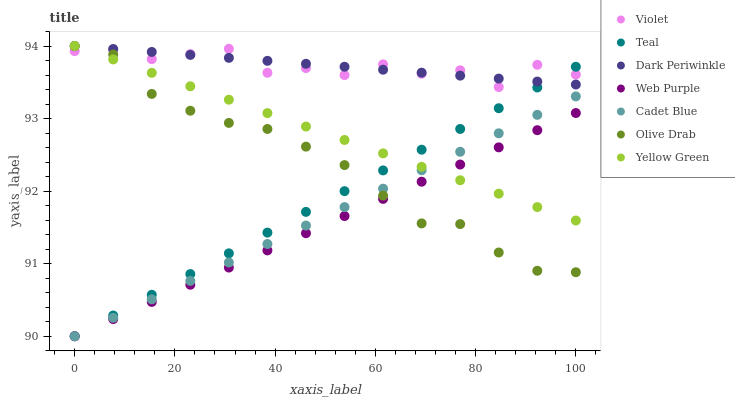Does Web Purple have the minimum area under the curve?
Answer yes or no. Yes. Does Dark Periwinkle have the maximum area under the curve?
Answer yes or no. Yes. Does Yellow Green have the minimum area under the curve?
Answer yes or no. No. Does Yellow Green have the maximum area under the curve?
Answer yes or no. No. Is Dark Periwinkle the smoothest?
Answer yes or no. Yes. Is Violet the roughest?
Answer yes or no. Yes. Is Yellow Green the smoothest?
Answer yes or no. No. Is Yellow Green the roughest?
Answer yes or no. No. Does Cadet Blue have the lowest value?
Answer yes or no. Yes. Does Yellow Green have the lowest value?
Answer yes or no. No. Does Olive Drab have the highest value?
Answer yes or no. Yes. Does Web Purple have the highest value?
Answer yes or no. No. Is Cadet Blue less than Dark Periwinkle?
Answer yes or no. Yes. Is Dark Periwinkle greater than Web Purple?
Answer yes or no. Yes. Does Olive Drab intersect Yellow Green?
Answer yes or no. Yes. Is Olive Drab less than Yellow Green?
Answer yes or no. No. Is Olive Drab greater than Yellow Green?
Answer yes or no. No. Does Cadet Blue intersect Dark Periwinkle?
Answer yes or no. No. 